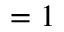Convert formula to latex. <formula><loc_0><loc_0><loc_500><loc_500>= 1</formula> 